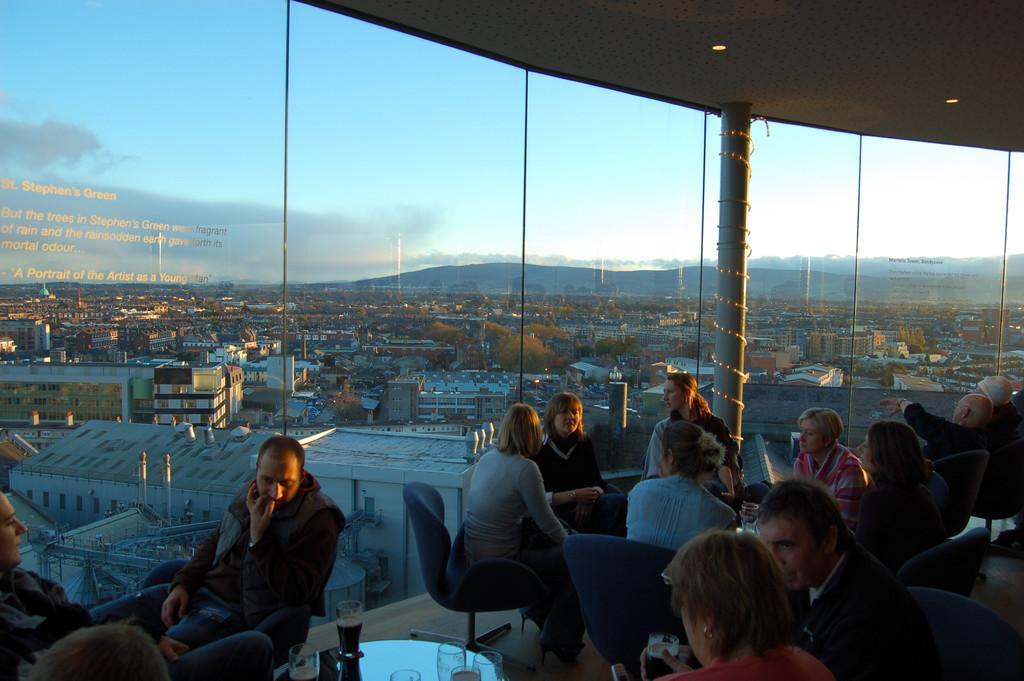How would you summarize this image in a sentence or two? In the foreground of the image there are people sitting on chairs. There is a glass wall,through which we can see mountains,trees,houses. At the top of the image there is a ceiling with lights. 